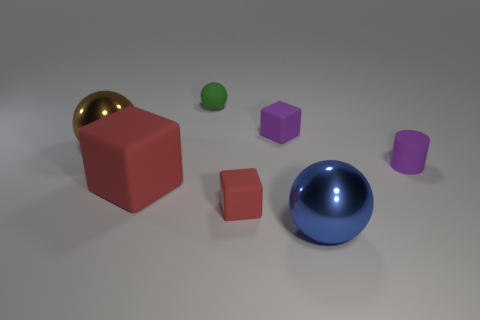Are there any other things that are the same color as the cylinder?
Provide a succinct answer. Yes. What shape is the big metallic thing in front of the large red matte cube that is on the left side of the small purple rubber cylinder that is on the right side of the purple rubber block?
Your response must be concise. Sphere. Is the size of the sphere in front of the tiny purple matte cylinder the same as the ball that is to the left of the tiny green matte object?
Give a very brief answer. Yes. How many other green balls are made of the same material as the small sphere?
Offer a very short reply. 0. How many purple objects are to the right of the metallic sphere on the right side of the large metal ball behind the tiny red rubber thing?
Make the answer very short. 1. Do the big blue object and the tiny green object have the same shape?
Give a very brief answer. Yes. Is there another small matte thing that has the same shape as the blue thing?
Your answer should be compact. Yes. There is a green thing that is the same size as the purple cylinder; what is its shape?
Offer a terse response. Sphere. There is a purple object to the right of the ball that is in front of the red matte block that is in front of the large red thing; what is its material?
Keep it short and to the point. Rubber. Do the brown shiny thing and the purple cylinder have the same size?
Your answer should be very brief. No. 